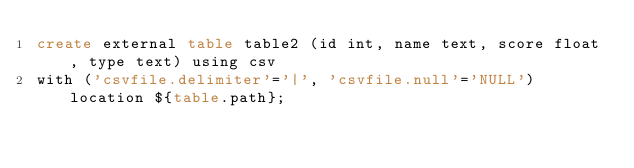<code> <loc_0><loc_0><loc_500><loc_500><_SQL_>create external table table2 (id int, name text, score float, type text) using csv
with ('csvfile.delimiter'='|', 'csvfile.null'='NULL') location ${table.path};

</code> 